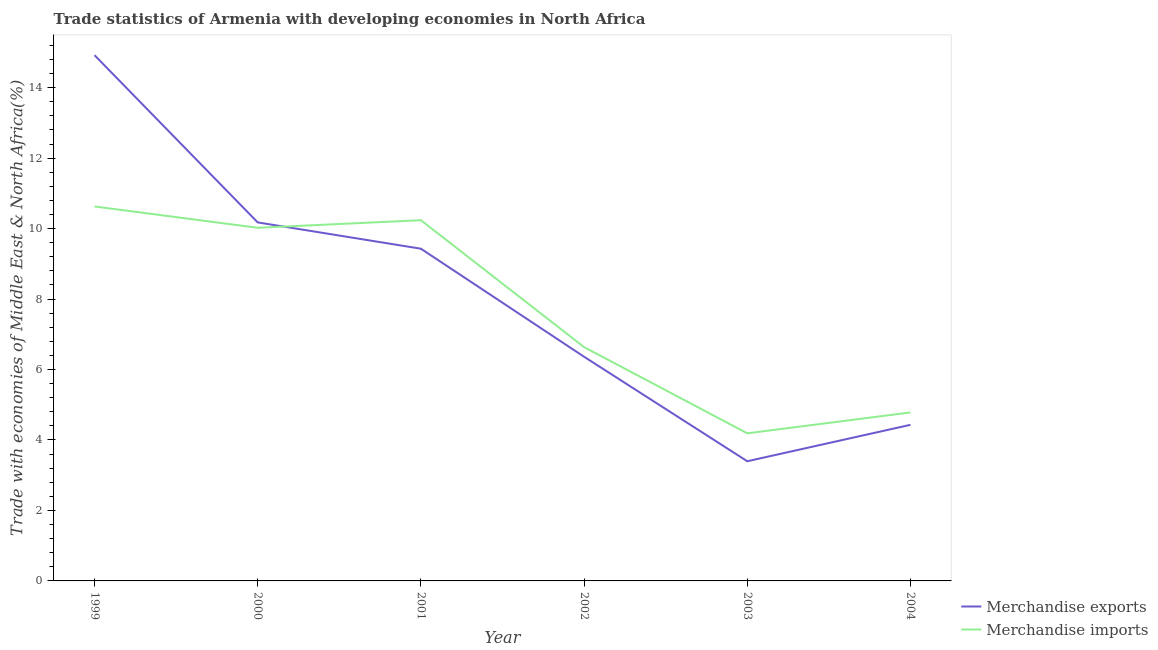Does the line corresponding to merchandise imports intersect with the line corresponding to merchandise exports?
Keep it short and to the point. Yes. Is the number of lines equal to the number of legend labels?
Your answer should be very brief. Yes. What is the merchandise imports in 1999?
Provide a short and direct response. 10.63. Across all years, what is the maximum merchandise exports?
Provide a succinct answer. 14.92. Across all years, what is the minimum merchandise imports?
Offer a terse response. 4.19. In which year was the merchandise exports maximum?
Offer a terse response. 1999. What is the total merchandise imports in the graph?
Provide a succinct answer. 46.49. What is the difference between the merchandise exports in 1999 and that in 2002?
Keep it short and to the point. 8.56. What is the difference between the merchandise exports in 2003 and the merchandise imports in 2004?
Provide a succinct answer. -1.39. What is the average merchandise exports per year?
Your answer should be very brief. 8.12. In the year 2001, what is the difference between the merchandise exports and merchandise imports?
Your response must be concise. -0.81. In how many years, is the merchandise exports greater than 5.2 %?
Offer a terse response. 4. What is the ratio of the merchandise exports in 1999 to that in 2002?
Keep it short and to the point. 2.35. Is the difference between the merchandise imports in 2000 and 2001 greater than the difference between the merchandise exports in 2000 and 2001?
Offer a terse response. No. What is the difference between the highest and the second highest merchandise exports?
Offer a very short reply. 4.75. What is the difference between the highest and the lowest merchandise exports?
Your answer should be very brief. 11.52. In how many years, is the merchandise imports greater than the average merchandise imports taken over all years?
Offer a terse response. 3. Is the merchandise exports strictly less than the merchandise imports over the years?
Ensure brevity in your answer.  No. How many lines are there?
Give a very brief answer. 2. What is the difference between two consecutive major ticks on the Y-axis?
Your answer should be very brief. 2. Are the values on the major ticks of Y-axis written in scientific E-notation?
Your answer should be very brief. No. Where does the legend appear in the graph?
Keep it short and to the point. Bottom right. What is the title of the graph?
Offer a terse response. Trade statistics of Armenia with developing economies in North Africa. Does "Pregnant women" appear as one of the legend labels in the graph?
Make the answer very short. No. What is the label or title of the Y-axis?
Your answer should be very brief. Trade with economies of Middle East & North Africa(%). What is the Trade with economies of Middle East & North Africa(%) in Merchandise exports in 1999?
Offer a very short reply. 14.92. What is the Trade with economies of Middle East & North Africa(%) of Merchandise imports in 1999?
Offer a very short reply. 10.63. What is the Trade with economies of Middle East & North Africa(%) of Merchandise exports in 2000?
Give a very brief answer. 10.17. What is the Trade with economies of Middle East & North Africa(%) of Merchandise imports in 2000?
Offer a terse response. 10.02. What is the Trade with economies of Middle East & North Africa(%) in Merchandise exports in 2001?
Your answer should be compact. 9.43. What is the Trade with economies of Middle East & North Africa(%) of Merchandise imports in 2001?
Make the answer very short. 10.24. What is the Trade with economies of Middle East & North Africa(%) of Merchandise exports in 2002?
Your answer should be compact. 6.36. What is the Trade with economies of Middle East & North Africa(%) of Merchandise imports in 2002?
Your response must be concise. 6.64. What is the Trade with economies of Middle East & North Africa(%) in Merchandise exports in 2003?
Provide a succinct answer. 3.4. What is the Trade with economies of Middle East & North Africa(%) in Merchandise imports in 2003?
Provide a succinct answer. 4.19. What is the Trade with economies of Middle East & North Africa(%) in Merchandise exports in 2004?
Offer a terse response. 4.43. What is the Trade with economies of Middle East & North Africa(%) of Merchandise imports in 2004?
Your answer should be compact. 4.78. Across all years, what is the maximum Trade with economies of Middle East & North Africa(%) in Merchandise exports?
Give a very brief answer. 14.92. Across all years, what is the maximum Trade with economies of Middle East & North Africa(%) in Merchandise imports?
Ensure brevity in your answer.  10.63. Across all years, what is the minimum Trade with economies of Middle East & North Africa(%) in Merchandise exports?
Give a very brief answer. 3.4. Across all years, what is the minimum Trade with economies of Middle East & North Africa(%) in Merchandise imports?
Ensure brevity in your answer.  4.19. What is the total Trade with economies of Middle East & North Africa(%) in Merchandise exports in the graph?
Ensure brevity in your answer.  48.71. What is the total Trade with economies of Middle East & North Africa(%) in Merchandise imports in the graph?
Ensure brevity in your answer.  46.49. What is the difference between the Trade with economies of Middle East & North Africa(%) of Merchandise exports in 1999 and that in 2000?
Your response must be concise. 4.75. What is the difference between the Trade with economies of Middle East & North Africa(%) in Merchandise imports in 1999 and that in 2000?
Keep it short and to the point. 0.61. What is the difference between the Trade with economies of Middle East & North Africa(%) of Merchandise exports in 1999 and that in 2001?
Make the answer very short. 5.49. What is the difference between the Trade with economies of Middle East & North Africa(%) in Merchandise imports in 1999 and that in 2001?
Keep it short and to the point. 0.39. What is the difference between the Trade with economies of Middle East & North Africa(%) of Merchandise exports in 1999 and that in 2002?
Ensure brevity in your answer.  8.56. What is the difference between the Trade with economies of Middle East & North Africa(%) of Merchandise imports in 1999 and that in 2002?
Your answer should be very brief. 3.99. What is the difference between the Trade with economies of Middle East & North Africa(%) in Merchandise exports in 1999 and that in 2003?
Your answer should be very brief. 11.52. What is the difference between the Trade with economies of Middle East & North Africa(%) of Merchandise imports in 1999 and that in 2003?
Your answer should be very brief. 6.44. What is the difference between the Trade with economies of Middle East & North Africa(%) of Merchandise exports in 1999 and that in 2004?
Make the answer very short. 10.49. What is the difference between the Trade with economies of Middle East & North Africa(%) in Merchandise imports in 1999 and that in 2004?
Give a very brief answer. 5.85. What is the difference between the Trade with economies of Middle East & North Africa(%) of Merchandise exports in 2000 and that in 2001?
Offer a terse response. 0.75. What is the difference between the Trade with economies of Middle East & North Africa(%) of Merchandise imports in 2000 and that in 2001?
Offer a terse response. -0.22. What is the difference between the Trade with economies of Middle East & North Africa(%) in Merchandise exports in 2000 and that in 2002?
Keep it short and to the point. 3.81. What is the difference between the Trade with economies of Middle East & North Africa(%) in Merchandise imports in 2000 and that in 2002?
Offer a terse response. 3.39. What is the difference between the Trade with economies of Middle East & North Africa(%) in Merchandise exports in 2000 and that in 2003?
Ensure brevity in your answer.  6.78. What is the difference between the Trade with economies of Middle East & North Africa(%) in Merchandise imports in 2000 and that in 2003?
Ensure brevity in your answer.  5.83. What is the difference between the Trade with economies of Middle East & North Africa(%) in Merchandise exports in 2000 and that in 2004?
Offer a terse response. 5.74. What is the difference between the Trade with economies of Middle East & North Africa(%) of Merchandise imports in 2000 and that in 2004?
Ensure brevity in your answer.  5.24. What is the difference between the Trade with economies of Middle East & North Africa(%) in Merchandise exports in 2001 and that in 2002?
Your answer should be compact. 3.07. What is the difference between the Trade with economies of Middle East & North Africa(%) in Merchandise imports in 2001 and that in 2002?
Provide a short and direct response. 3.6. What is the difference between the Trade with economies of Middle East & North Africa(%) of Merchandise exports in 2001 and that in 2003?
Keep it short and to the point. 6.03. What is the difference between the Trade with economies of Middle East & North Africa(%) of Merchandise imports in 2001 and that in 2003?
Your answer should be very brief. 6.05. What is the difference between the Trade with economies of Middle East & North Africa(%) in Merchandise exports in 2001 and that in 2004?
Your answer should be very brief. 5. What is the difference between the Trade with economies of Middle East & North Africa(%) in Merchandise imports in 2001 and that in 2004?
Provide a succinct answer. 5.46. What is the difference between the Trade with economies of Middle East & North Africa(%) of Merchandise exports in 2002 and that in 2003?
Give a very brief answer. 2.97. What is the difference between the Trade with economies of Middle East & North Africa(%) in Merchandise imports in 2002 and that in 2003?
Give a very brief answer. 2.45. What is the difference between the Trade with economies of Middle East & North Africa(%) in Merchandise exports in 2002 and that in 2004?
Give a very brief answer. 1.93. What is the difference between the Trade with economies of Middle East & North Africa(%) in Merchandise imports in 2002 and that in 2004?
Offer a very short reply. 1.85. What is the difference between the Trade with economies of Middle East & North Africa(%) in Merchandise exports in 2003 and that in 2004?
Keep it short and to the point. -1.03. What is the difference between the Trade with economies of Middle East & North Africa(%) in Merchandise imports in 2003 and that in 2004?
Provide a succinct answer. -0.59. What is the difference between the Trade with economies of Middle East & North Africa(%) of Merchandise exports in 1999 and the Trade with economies of Middle East & North Africa(%) of Merchandise imports in 2000?
Offer a very short reply. 4.9. What is the difference between the Trade with economies of Middle East & North Africa(%) of Merchandise exports in 1999 and the Trade with economies of Middle East & North Africa(%) of Merchandise imports in 2001?
Keep it short and to the point. 4.68. What is the difference between the Trade with economies of Middle East & North Africa(%) of Merchandise exports in 1999 and the Trade with economies of Middle East & North Africa(%) of Merchandise imports in 2002?
Keep it short and to the point. 8.29. What is the difference between the Trade with economies of Middle East & North Africa(%) in Merchandise exports in 1999 and the Trade with economies of Middle East & North Africa(%) in Merchandise imports in 2003?
Provide a short and direct response. 10.73. What is the difference between the Trade with economies of Middle East & North Africa(%) of Merchandise exports in 1999 and the Trade with economies of Middle East & North Africa(%) of Merchandise imports in 2004?
Your answer should be very brief. 10.14. What is the difference between the Trade with economies of Middle East & North Africa(%) of Merchandise exports in 2000 and the Trade with economies of Middle East & North Africa(%) of Merchandise imports in 2001?
Provide a succinct answer. -0.06. What is the difference between the Trade with economies of Middle East & North Africa(%) of Merchandise exports in 2000 and the Trade with economies of Middle East & North Africa(%) of Merchandise imports in 2002?
Keep it short and to the point. 3.54. What is the difference between the Trade with economies of Middle East & North Africa(%) of Merchandise exports in 2000 and the Trade with economies of Middle East & North Africa(%) of Merchandise imports in 2003?
Provide a short and direct response. 5.99. What is the difference between the Trade with economies of Middle East & North Africa(%) of Merchandise exports in 2000 and the Trade with economies of Middle East & North Africa(%) of Merchandise imports in 2004?
Give a very brief answer. 5.39. What is the difference between the Trade with economies of Middle East & North Africa(%) of Merchandise exports in 2001 and the Trade with economies of Middle East & North Africa(%) of Merchandise imports in 2002?
Your answer should be very brief. 2.79. What is the difference between the Trade with economies of Middle East & North Africa(%) of Merchandise exports in 2001 and the Trade with economies of Middle East & North Africa(%) of Merchandise imports in 2003?
Make the answer very short. 5.24. What is the difference between the Trade with economies of Middle East & North Africa(%) of Merchandise exports in 2001 and the Trade with economies of Middle East & North Africa(%) of Merchandise imports in 2004?
Ensure brevity in your answer.  4.65. What is the difference between the Trade with economies of Middle East & North Africa(%) in Merchandise exports in 2002 and the Trade with economies of Middle East & North Africa(%) in Merchandise imports in 2003?
Make the answer very short. 2.17. What is the difference between the Trade with economies of Middle East & North Africa(%) in Merchandise exports in 2002 and the Trade with economies of Middle East & North Africa(%) in Merchandise imports in 2004?
Offer a very short reply. 1.58. What is the difference between the Trade with economies of Middle East & North Africa(%) of Merchandise exports in 2003 and the Trade with economies of Middle East & North Africa(%) of Merchandise imports in 2004?
Make the answer very short. -1.39. What is the average Trade with economies of Middle East & North Africa(%) of Merchandise exports per year?
Your answer should be very brief. 8.12. What is the average Trade with economies of Middle East & North Africa(%) of Merchandise imports per year?
Offer a very short reply. 7.75. In the year 1999, what is the difference between the Trade with economies of Middle East & North Africa(%) of Merchandise exports and Trade with economies of Middle East & North Africa(%) of Merchandise imports?
Your answer should be compact. 4.29. In the year 2000, what is the difference between the Trade with economies of Middle East & North Africa(%) of Merchandise exports and Trade with economies of Middle East & North Africa(%) of Merchandise imports?
Provide a short and direct response. 0.15. In the year 2001, what is the difference between the Trade with economies of Middle East & North Africa(%) of Merchandise exports and Trade with economies of Middle East & North Africa(%) of Merchandise imports?
Ensure brevity in your answer.  -0.81. In the year 2002, what is the difference between the Trade with economies of Middle East & North Africa(%) of Merchandise exports and Trade with economies of Middle East & North Africa(%) of Merchandise imports?
Make the answer very short. -0.27. In the year 2003, what is the difference between the Trade with economies of Middle East & North Africa(%) of Merchandise exports and Trade with economies of Middle East & North Africa(%) of Merchandise imports?
Offer a terse response. -0.79. In the year 2004, what is the difference between the Trade with economies of Middle East & North Africa(%) in Merchandise exports and Trade with economies of Middle East & North Africa(%) in Merchandise imports?
Your answer should be very brief. -0.35. What is the ratio of the Trade with economies of Middle East & North Africa(%) in Merchandise exports in 1999 to that in 2000?
Make the answer very short. 1.47. What is the ratio of the Trade with economies of Middle East & North Africa(%) in Merchandise imports in 1999 to that in 2000?
Offer a very short reply. 1.06. What is the ratio of the Trade with economies of Middle East & North Africa(%) in Merchandise exports in 1999 to that in 2001?
Your answer should be very brief. 1.58. What is the ratio of the Trade with economies of Middle East & North Africa(%) in Merchandise imports in 1999 to that in 2001?
Ensure brevity in your answer.  1.04. What is the ratio of the Trade with economies of Middle East & North Africa(%) of Merchandise exports in 1999 to that in 2002?
Provide a short and direct response. 2.35. What is the ratio of the Trade with economies of Middle East & North Africa(%) in Merchandise imports in 1999 to that in 2002?
Offer a very short reply. 1.6. What is the ratio of the Trade with economies of Middle East & North Africa(%) in Merchandise exports in 1999 to that in 2003?
Offer a very short reply. 4.39. What is the ratio of the Trade with economies of Middle East & North Africa(%) in Merchandise imports in 1999 to that in 2003?
Give a very brief answer. 2.54. What is the ratio of the Trade with economies of Middle East & North Africa(%) in Merchandise exports in 1999 to that in 2004?
Your answer should be compact. 3.37. What is the ratio of the Trade with economies of Middle East & North Africa(%) in Merchandise imports in 1999 to that in 2004?
Provide a succinct answer. 2.22. What is the ratio of the Trade with economies of Middle East & North Africa(%) in Merchandise exports in 2000 to that in 2001?
Ensure brevity in your answer.  1.08. What is the ratio of the Trade with economies of Middle East & North Africa(%) of Merchandise exports in 2000 to that in 2002?
Make the answer very short. 1.6. What is the ratio of the Trade with economies of Middle East & North Africa(%) of Merchandise imports in 2000 to that in 2002?
Ensure brevity in your answer.  1.51. What is the ratio of the Trade with economies of Middle East & North Africa(%) of Merchandise exports in 2000 to that in 2003?
Keep it short and to the point. 3. What is the ratio of the Trade with economies of Middle East & North Africa(%) in Merchandise imports in 2000 to that in 2003?
Your answer should be compact. 2.39. What is the ratio of the Trade with economies of Middle East & North Africa(%) in Merchandise exports in 2000 to that in 2004?
Provide a short and direct response. 2.3. What is the ratio of the Trade with economies of Middle East & North Africa(%) of Merchandise imports in 2000 to that in 2004?
Your answer should be very brief. 2.1. What is the ratio of the Trade with economies of Middle East & North Africa(%) of Merchandise exports in 2001 to that in 2002?
Provide a succinct answer. 1.48. What is the ratio of the Trade with economies of Middle East & North Africa(%) of Merchandise imports in 2001 to that in 2002?
Provide a short and direct response. 1.54. What is the ratio of the Trade with economies of Middle East & North Africa(%) in Merchandise exports in 2001 to that in 2003?
Your response must be concise. 2.78. What is the ratio of the Trade with economies of Middle East & North Africa(%) in Merchandise imports in 2001 to that in 2003?
Offer a terse response. 2.44. What is the ratio of the Trade with economies of Middle East & North Africa(%) of Merchandise exports in 2001 to that in 2004?
Offer a very short reply. 2.13. What is the ratio of the Trade with economies of Middle East & North Africa(%) of Merchandise imports in 2001 to that in 2004?
Give a very brief answer. 2.14. What is the ratio of the Trade with economies of Middle East & North Africa(%) of Merchandise exports in 2002 to that in 2003?
Provide a succinct answer. 1.87. What is the ratio of the Trade with economies of Middle East & North Africa(%) in Merchandise imports in 2002 to that in 2003?
Ensure brevity in your answer.  1.58. What is the ratio of the Trade with economies of Middle East & North Africa(%) of Merchandise exports in 2002 to that in 2004?
Your answer should be compact. 1.44. What is the ratio of the Trade with economies of Middle East & North Africa(%) of Merchandise imports in 2002 to that in 2004?
Give a very brief answer. 1.39. What is the ratio of the Trade with economies of Middle East & North Africa(%) of Merchandise exports in 2003 to that in 2004?
Keep it short and to the point. 0.77. What is the ratio of the Trade with economies of Middle East & North Africa(%) of Merchandise imports in 2003 to that in 2004?
Give a very brief answer. 0.88. What is the difference between the highest and the second highest Trade with economies of Middle East & North Africa(%) in Merchandise exports?
Your answer should be very brief. 4.75. What is the difference between the highest and the second highest Trade with economies of Middle East & North Africa(%) of Merchandise imports?
Your answer should be compact. 0.39. What is the difference between the highest and the lowest Trade with economies of Middle East & North Africa(%) in Merchandise exports?
Make the answer very short. 11.52. What is the difference between the highest and the lowest Trade with economies of Middle East & North Africa(%) of Merchandise imports?
Provide a succinct answer. 6.44. 